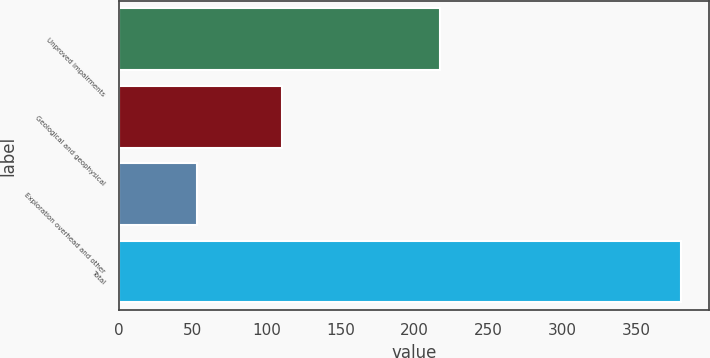Convert chart. <chart><loc_0><loc_0><loc_500><loc_500><bar_chart><fcel>Unproved impairments<fcel>Geological and geophysical<fcel>Exploration overhead and other<fcel>Total<nl><fcel>217<fcel>110<fcel>53<fcel>380<nl></chart> 